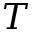Convert formula to latex. <formula><loc_0><loc_0><loc_500><loc_500>T</formula> 